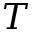Convert formula to latex. <formula><loc_0><loc_0><loc_500><loc_500>T</formula> 